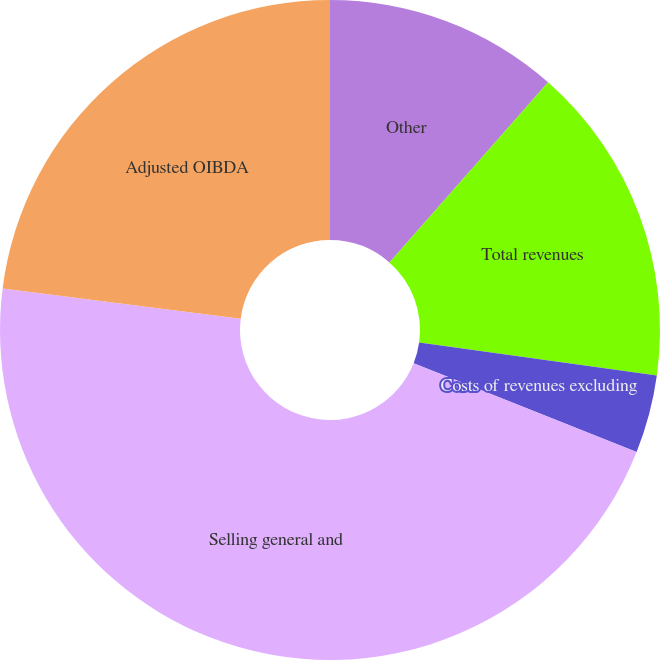Convert chart. <chart><loc_0><loc_0><loc_500><loc_500><pie_chart><fcel>Other<fcel>Total revenues<fcel>Costs of revenues excluding<fcel>Selling general and<fcel>Adjusted OIBDA<nl><fcel>11.49%<fcel>15.71%<fcel>3.83%<fcel>45.98%<fcel>22.99%<nl></chart> 